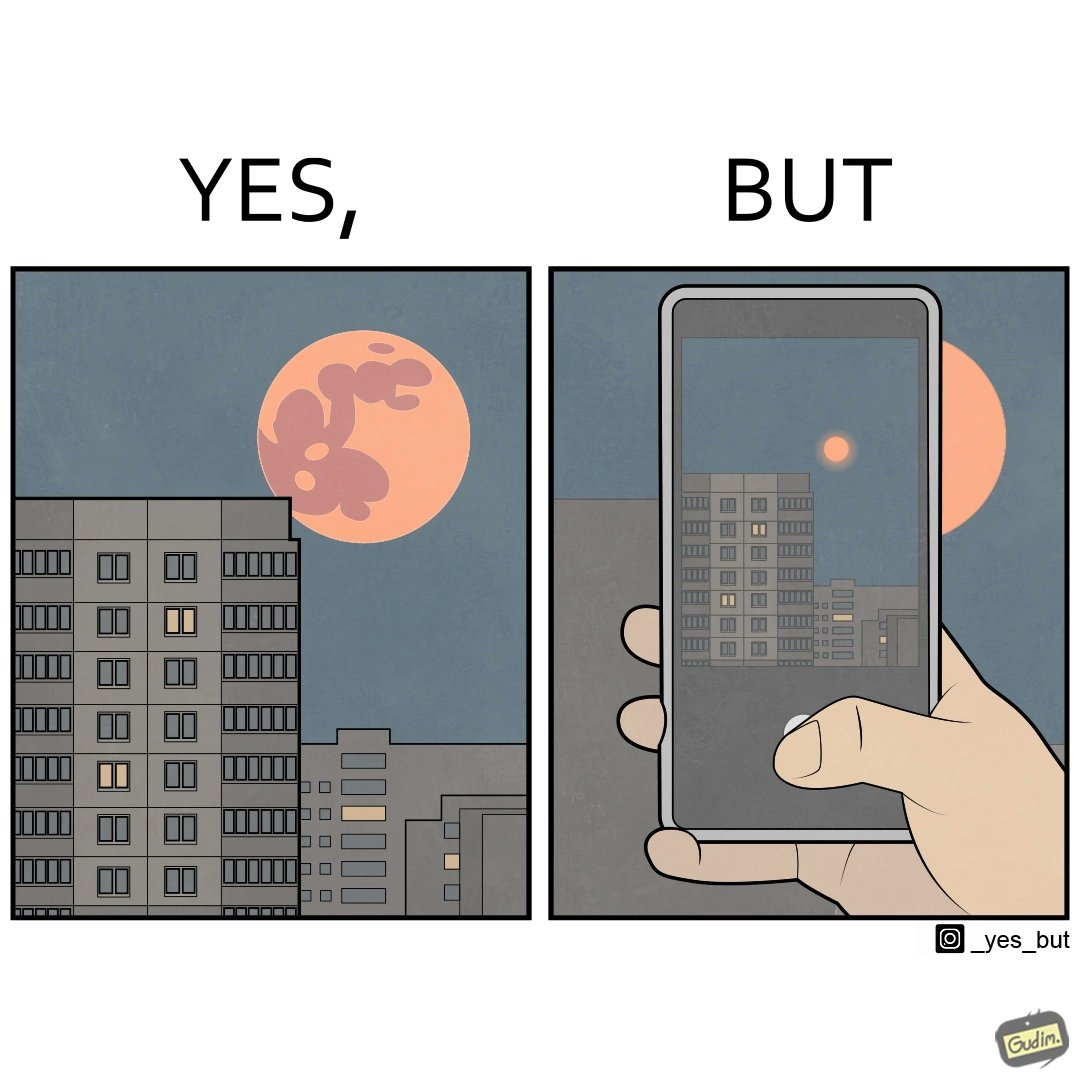Describe what you see in this image. The image is ironic, because the phone is not able to capture the real beauty of the view which the viewer can see by their naked eyes 